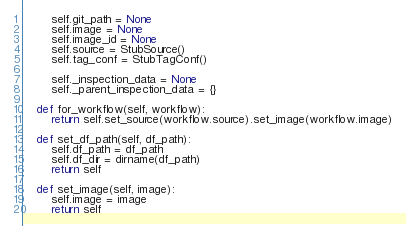Convert code to text. <code><loc_0><loc_0><loc_500><loc_500><_Python_>        self.git_path = None
        self.image = None
        self.image_id = None
        self.source = StubSource()
        self.tag_conf = StubTagConf()

        self._inspection_data = None
        self._parent_inspection_data = {}

    def for_workflow(self, workflow):
        return self.set_source(workflow.source).set_image(workflow.image)

    def set_df_path(self, df_path):
        self.df_path = df_path
        self.df_dir = dirname(df_path)
        return self

    def set_image(self, image):
        self.image = image
        return self
</code> 